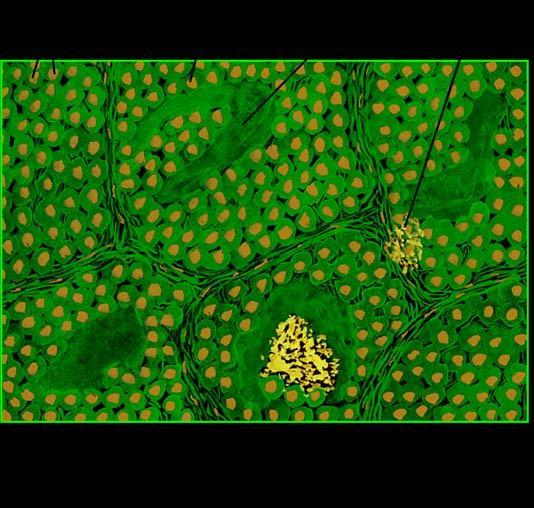does amyloid show congophilia which depicts apple-green birefringence under polarising microscopy?
Answer the question using a single word or phrase. Yes 